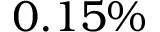<formula> <loc_0><loc_0><loc_500><loc_500>0 . 1 5 \%</formula> 